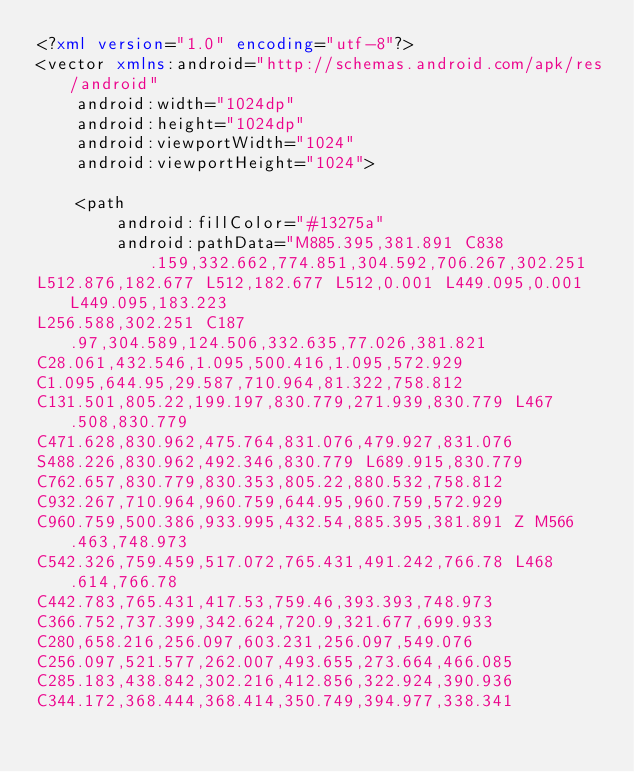<code> <loc_0><loc_0><loc_500><loc_500><_XML_><?xml version="1.0" encoding="utf-8"?>
<vector xmlns:android="http://schemas.android.com/apk/res/android"
    android:width="1024dp"
    android:height="1024dp"
    android:viewportWidth="1024"
    android:viewportHeight="1024">

    <path
        android:fillColor="#13275a"
        android:pathData="M885.395,381.891 C838.159,332.662,774.851,304.592,706.267,302.251
L512.876,182.677 L512,182.677 L512,0.001 L449.095,0.001 L449.095,183.223
L256.588,302.251 C187.97,304.589,124.506,332.635,77.026,381.821
C28.061,432.546,1.095,500.416,1.095,572.929
C1.095,644.95,29.587,710.964,81.322,758.812
C131.501,805.22,199.197,830.779,271.939,830.779 L467.508,830.779
C471.628,830.962,475.764,831.076,479.927,831.076
S488.226,830.962,492.346,830.779 L689.915,830.779
C762.657,830.779,830.353,805.22,880.532,758.812
C932.267,710.964,960.759,644.95,960.759,572.929
C960.759,500.386,933.995,432.54,885.395,381.891 Z M566.463,748.973
C542.326,759.459,517.072,765.431,491.242,766.78 L468.614,766.78
C442.783,765.431,417.53,759.46,393.393,748.973
C366.752,737.399,342.624,720.9,321.677,699.933
C280,658.216,256.097,603.231,256.097,549.076
C256.097,521.577,262.007,493.655,273.664,466.085
C285.183,438.842,302.216,412.856,322.924,390.936
C344.172,368.444,368.414,350.749,394.977,338.341</code> 